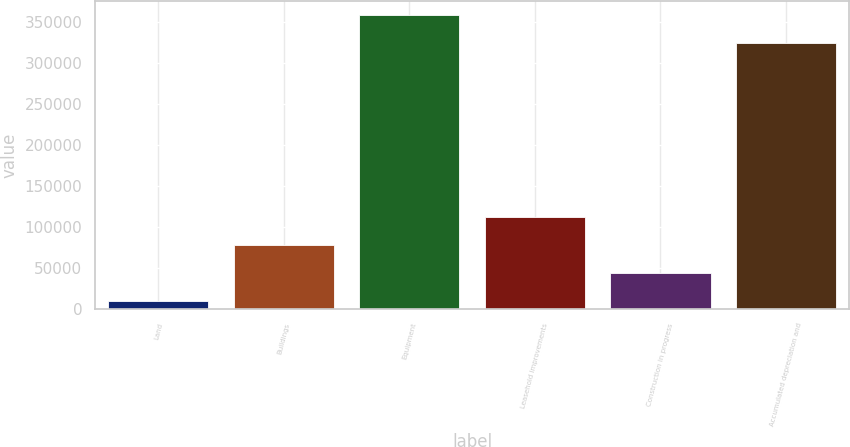Convert chart to OTSL. <chart><loc_0><loc_0><loc_500><loc_500><bar_chart><fcel>Land<fcel>Buildings<fcel>Equipment<fcel>Leasehold improvements<fcel>Construction in progress<fcel>Accumulated depreciation and<nl><fcel>9581<fcel>77899.4<fcel>358431<fcel>112059<fcel>43740.2<fcel>324272<nl></chart> 